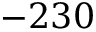Convert formula to latex. <formula><loc_0><loc_0><loc_500><loc_500>- 2 3 0</formula> 